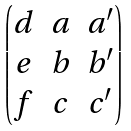<formula> <loc_0><loc_0><loc_500><loc_500>\begin{pmatrix} d & a & a ^ { \prime } \\ e & b & b ^ { \prime } \\ f & c & c ^ { \prime } \\ \end{pmatrix}</formula> 